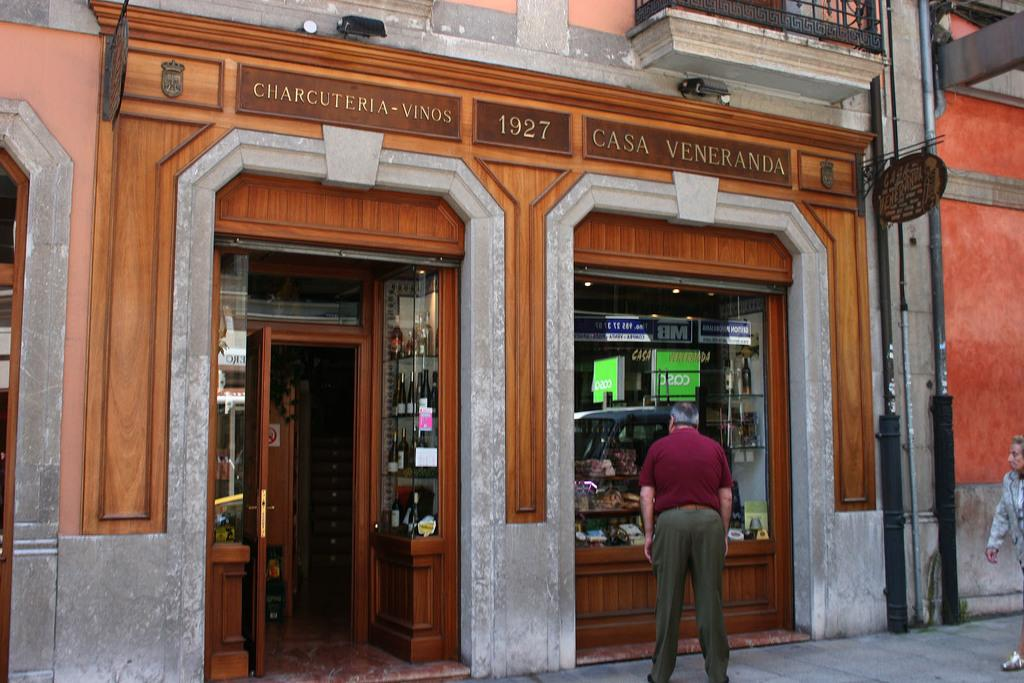Provide a one-sentence caption for the provided image. A man is looking into the window of Casa Veneranda. 